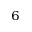<formula> <loc_0><loc_0><loc_500><loc_500>^ { 6 }</formula> 